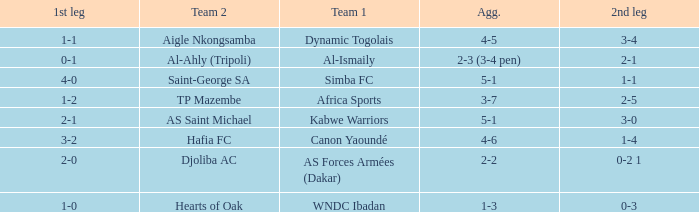What team played against Al-Ismaily (team 1)? Al-Ahly (Tripoli). 